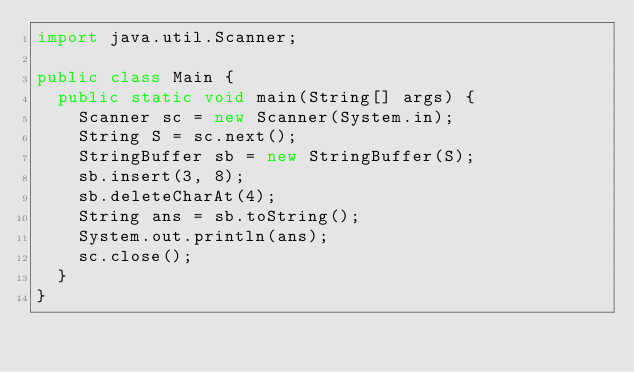Convert code to text. <code><loc_0><loc_0><loc_500><loc_500><_Java_>import java.util.Scanner;

public class Main {
	public static void main(String[] args) {
		Scanner sc = new Scanner(System.in);
		String S = sc.next();
		StringBuffer sb = new StringBuffer(S);
		sb.insert(3, 8);
		sb.deleteCharAt(4);
		String ans = sb.toString();
		System.out.println(ans);
		sc.close();
	}
}
</code> 